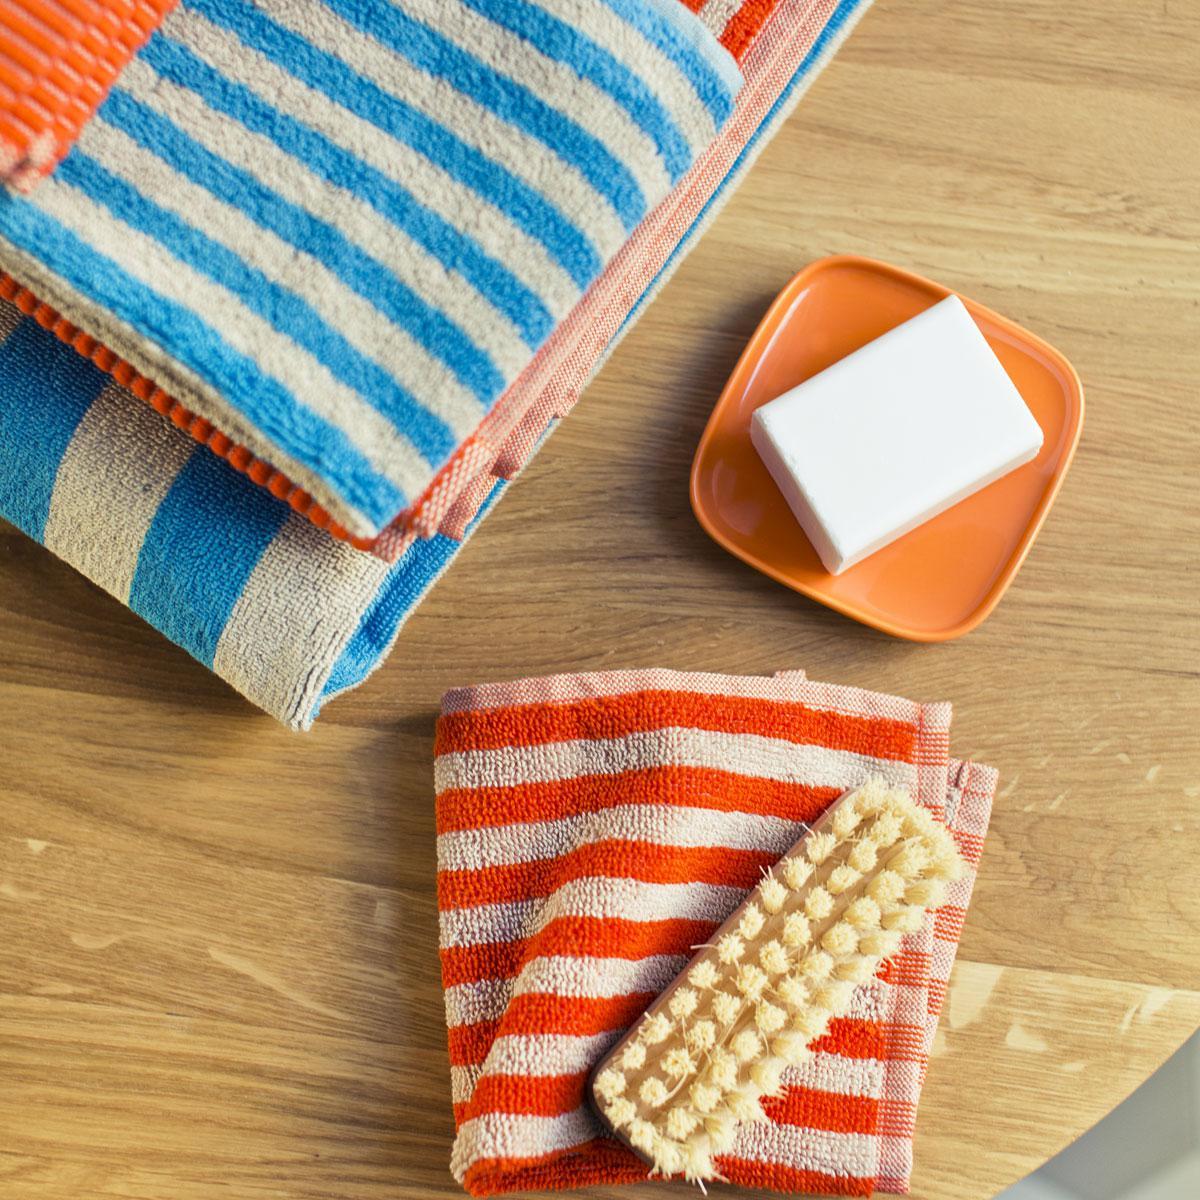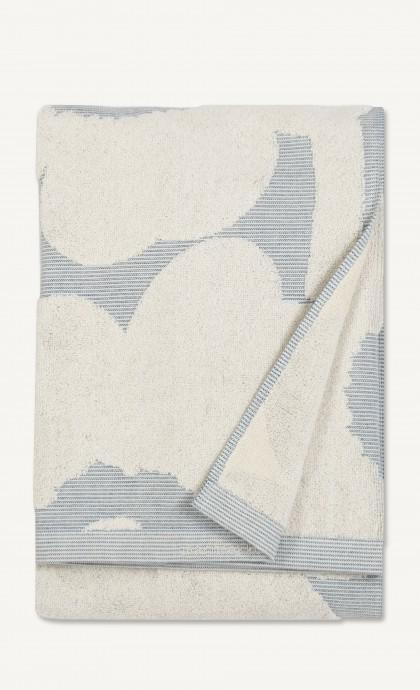The first image is the image on the left, the second image is the image on the right. Considering the images on both sides, is "Exactly one towel's bottom right corner is folded over." valid? Answer yes or no. Yes. 